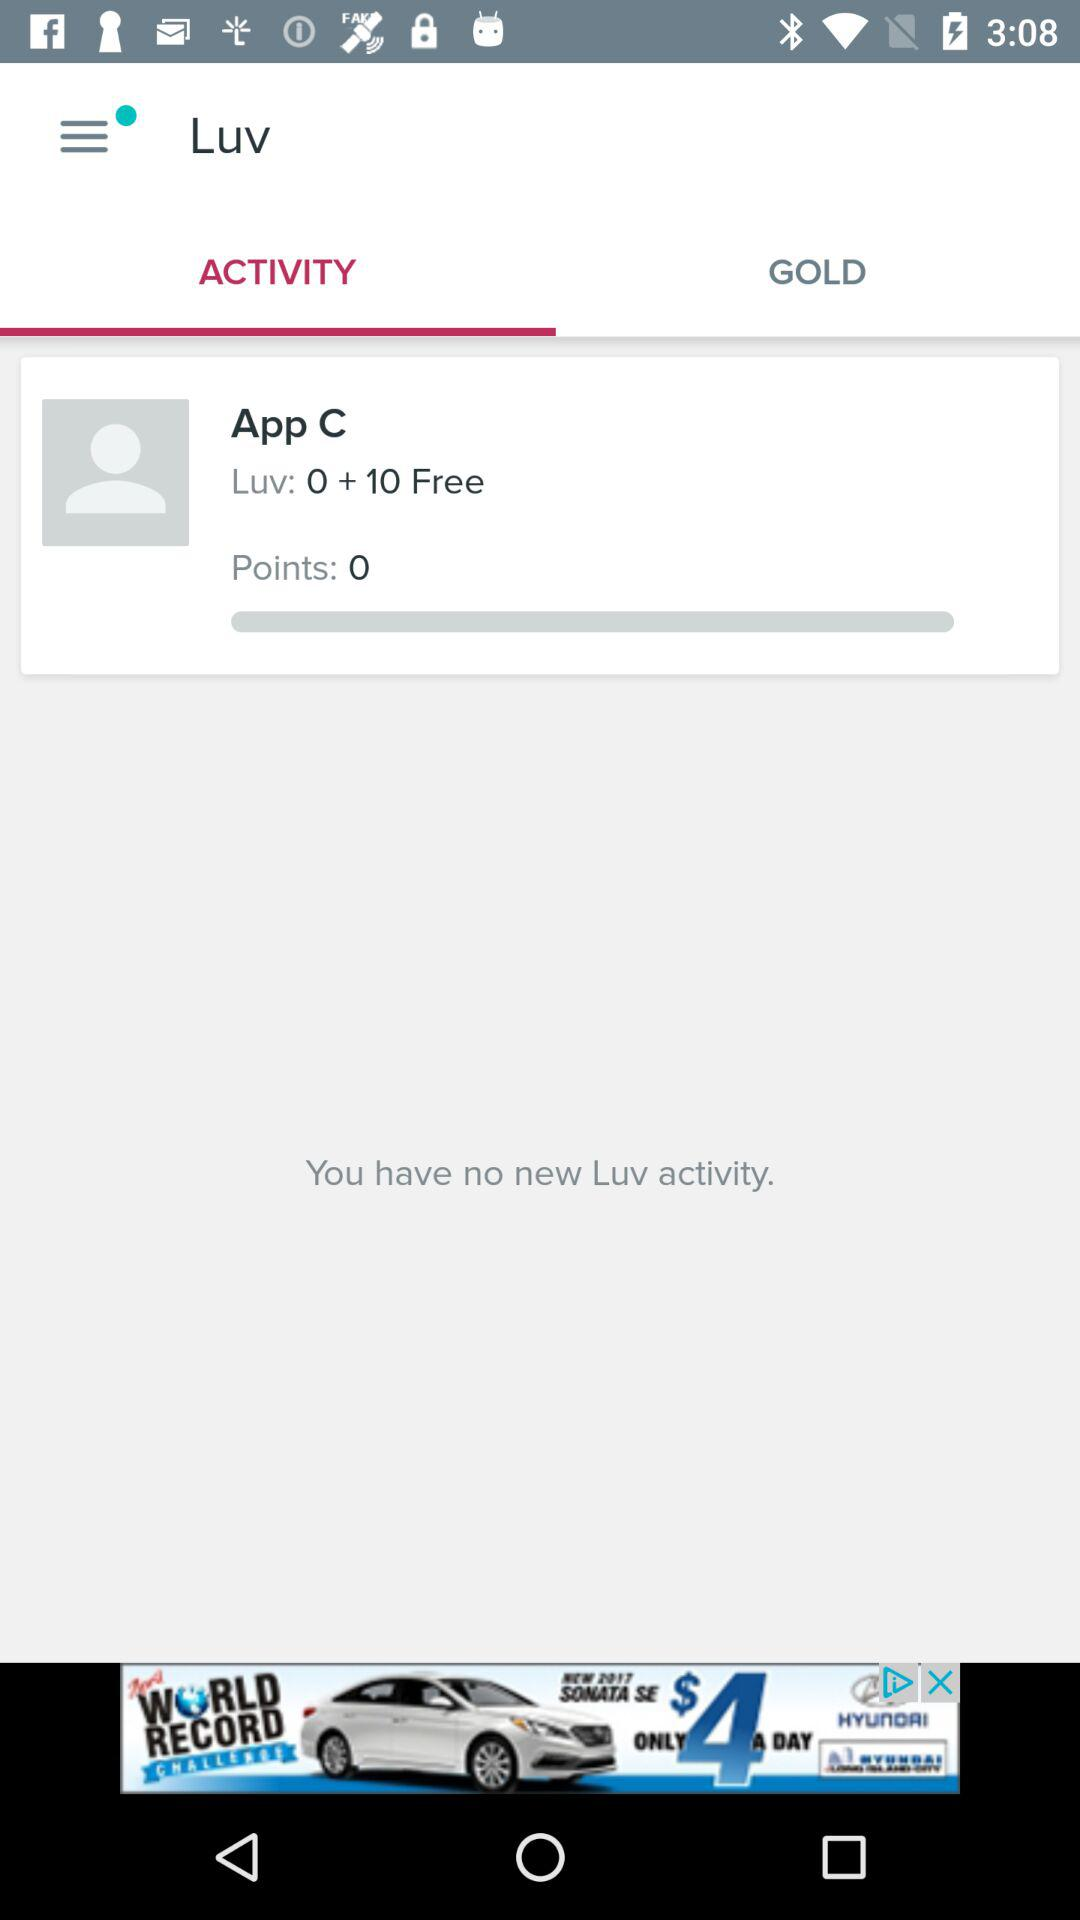How many Luv activities do I have?
Answer the question using a single word or phrase. 0 